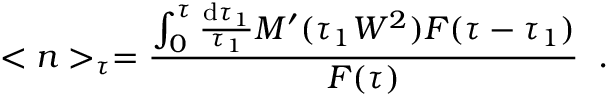<formula> <loc_0><loc_0><loc_500><loc_500>< n > _ { \tau } = \frac { \int _ { 0 } ^ { \tau } \frac { d \tau _ { 1 } } { \tau _ { 1 } } M ^ { \prime } ( \tau _ { 1 } W ^ { 2 } ) F ( \tau - \tau _ { 1 } ) } { F ( \tau ) } \, .</formula> 